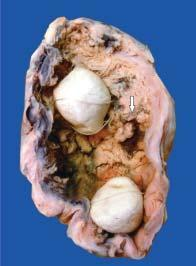what contains irregular, friable papillary growth arising from mucosa?
Answer the question using a single word or phrase. Lumen of the gallbladder 